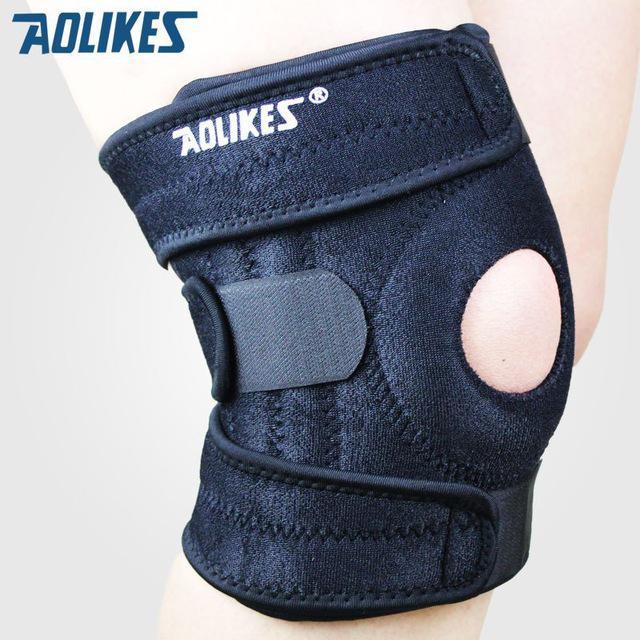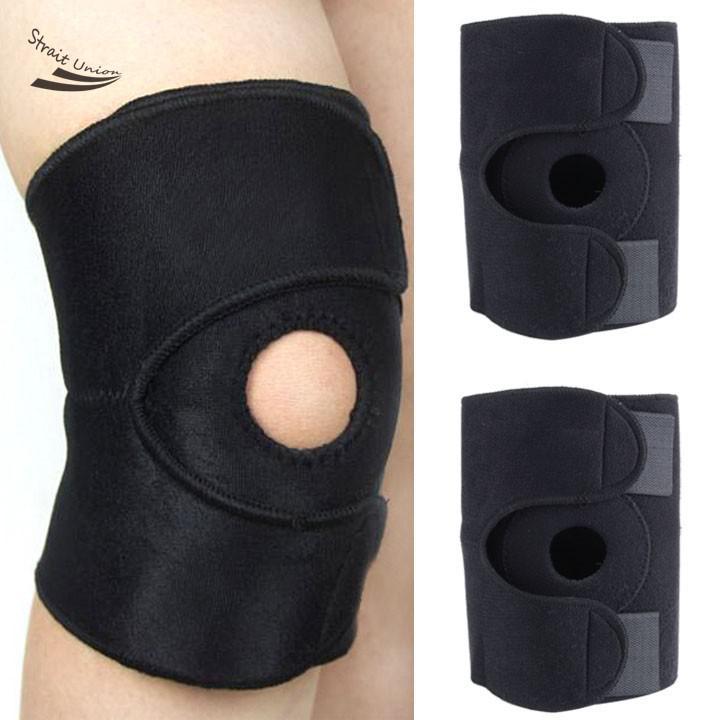The first image is the image on the left, the second image is the image on the right. Examine the images to the left and right. Is the description "All knee pads are black, and each image includes a pair of legs with at least one leg wearing a knee pad." accurate? Answer yes or no. Yes. The first image is the image on the left, the second image is the image on the right. Analyze the images presented: Is the assertion "In at least one image there are four kneepads." valid? Answer yes or no. No. 